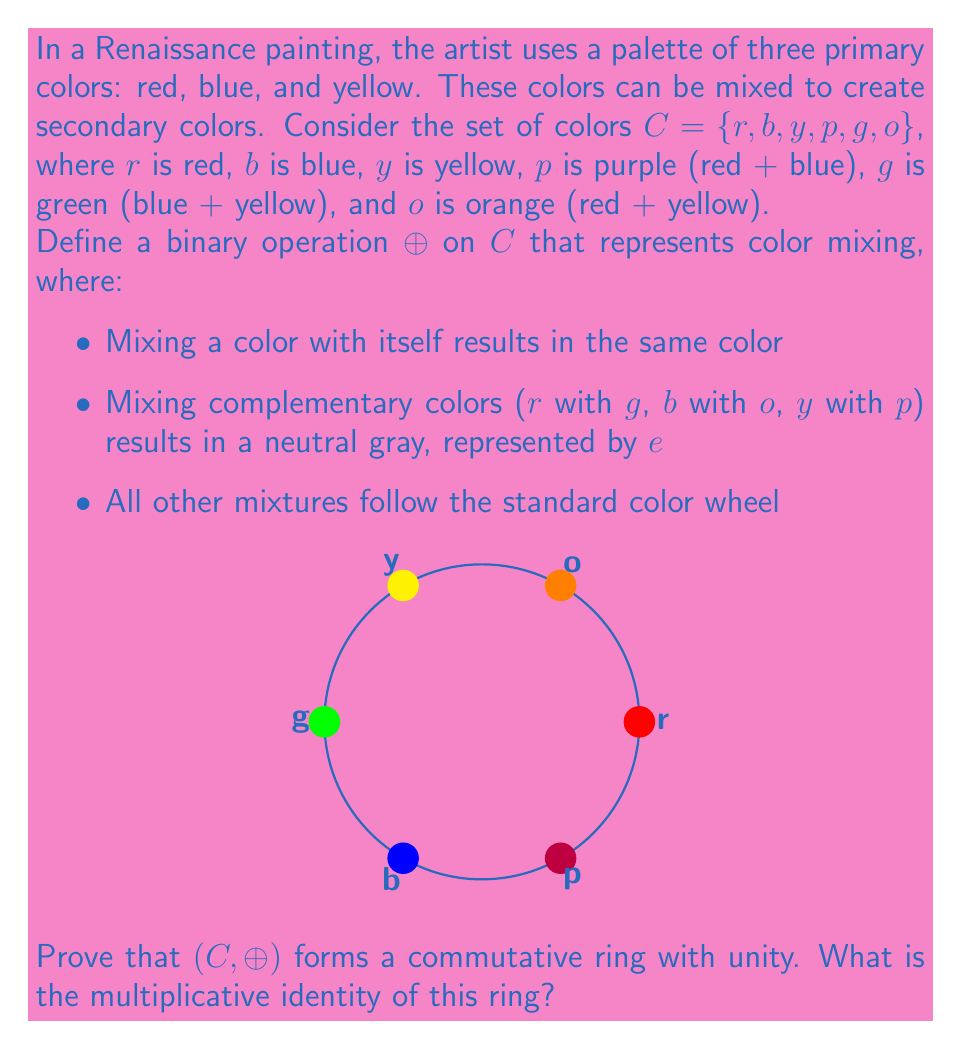Give your solution to this math problem. To prove that $(C, \oplus)$ forms a commutative ring with unity, we need to verify the following properties:

1. Closure: For all $a, b \in C$, $a \oplus b \in C$
2. Associativity: For all $a, b, c \in C$, $(a \oplus b) \oplus c = a \oplus (b \oplus c)$
3. Commutativity: For all $a, b \in C$, $a \oplus b = b \oplus a$
4. Identity element: There exists an $e \in C$ such that $a \oplus e = e \oplus a = a$ for all $a \in C$
5. Inverse elements: For each $a \in C$, there exists a $-a \in C$ such that $a \oplus (-a) = (-a) \oplus a = e$
6. Distributivity: For all $a, b, c \in C$, $a \oplus (b \oplus c) = (a \oplus b) \oplus (a \oplus c)$

Let's verify these properties:

1. Closure: The operation $\oplus$ is defined for all pairs of colors in $C$, and the result is always in $C$ (including $e$).

2. Associativity: This holds because the order of mixing three colors doesn't matter.

3. Commutativity: Mixing colors is commutative, so $a \oplus b = b \oplus a$ for all $a, b \in C$.

4. Identity element: The neutral gray $e$ acts as the identity element, as mixing any color with gray doesn't change the color.

5. Inverse elements: Each color has its complementary color as its inverse:
   $r \oplus g = g \oplus r = e$
   $b \oplus o = o \oplus b = e$
   $y \oplus p = p \oplus y = e$

6. Distributivity: This property holds because mixing a color with a mixture of two other colors is equivalent to mixing it with each color separately and then combining the results.

Therefore, $(C, \oplus)$ forms a commutative ring with unity. The multiplicative identity of this ring is the neutral gray $e$, as it acts as the identity element for the color mixing operation.
Answer: $e$ (neutral gray) 